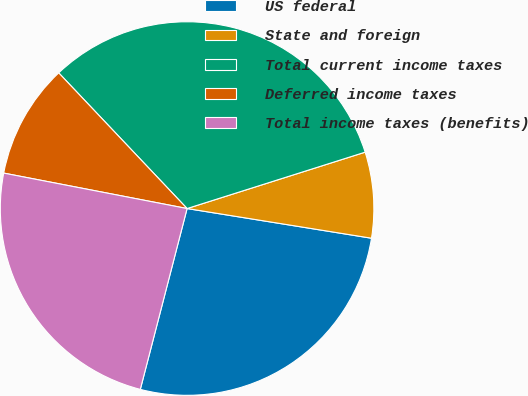Convert chart. <chart><loc_0><loc_0><loc_500><loc_500><pie_chart><fcel>US federal<fcel>State and foreign<fcel>Total current income taxes<fcel>Deferred income taxes<fcel>Total income taxes (benefits)<nl><fcel>26.49%<fcel>7.42%<fcel>32.18%<fcel>9.9%<fcel>24.01%<nl></chart> 